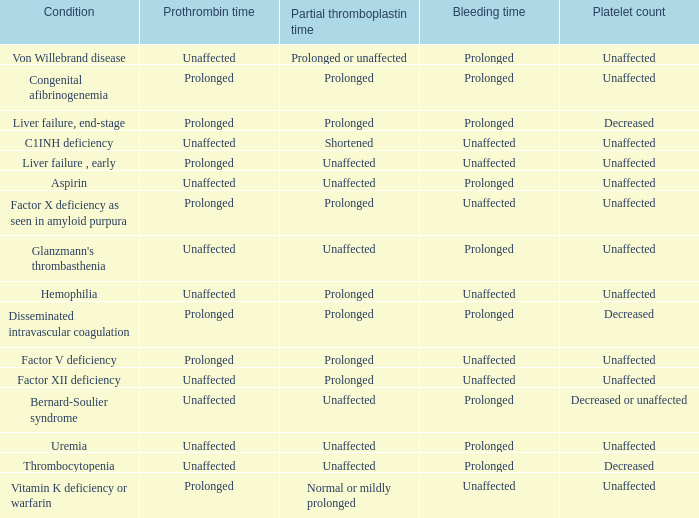Which partial thromboplastin time has a condition of liver failure , early? Unaffected. 